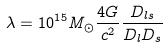<formula> <loc_0><loc_0><loc_500><loc_500>\lambda = 1 0 ^ { 1 5 } M _ { \odot } \frac { 4 G } { c ^ { 2 } } \frac { D _ { l s } } { D _ { l } D _ { s } }</formula> 